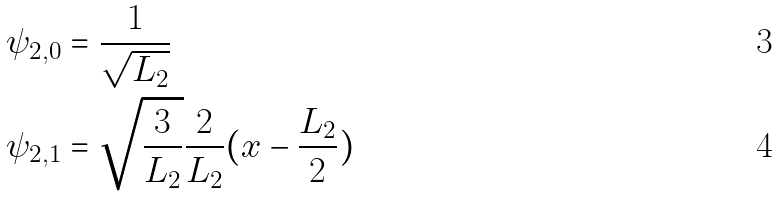<formula> <loc_0><loc_0><loc_500><loc_500>\psi _ { 2 , 0 } & = \frac { 1 } { \sqrt { L _ { 2 } } } \\ \psi _ { 2 , 1 } & = \sqrt { \frac { 3 } { L _ { 2 } } } \frac { 2 } { L _ { 2 } } ( x - \frac { L _ { 2 } } { 2 } )</formula> 